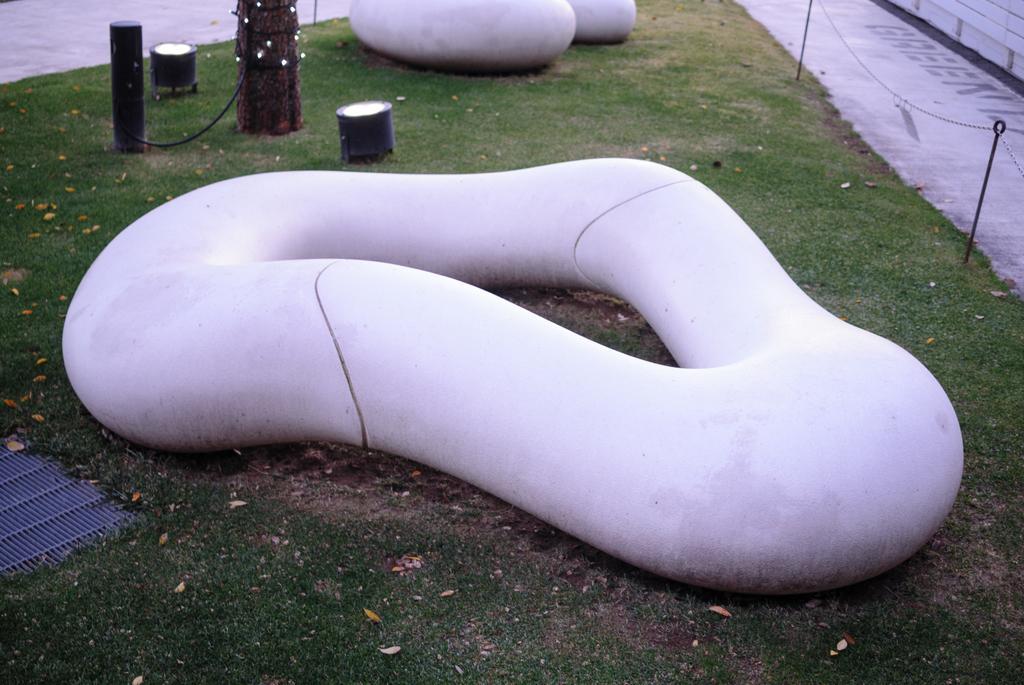How would you summarize this image in a sentence or two? In this image I can see the ground, some grass on the ground, few objects which are pink in color and few black colored poles. 